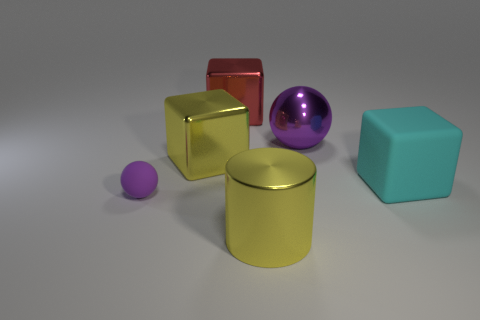There is a large object that is made of the same material as the small purple sphere; what is its color? The large object that appears to be made of the same material as the small purple sphere is the large purple sphere. Both spheres share a smooth, reflective surface indicative of a similar material composition, and both exhibit a rich purple hue. 